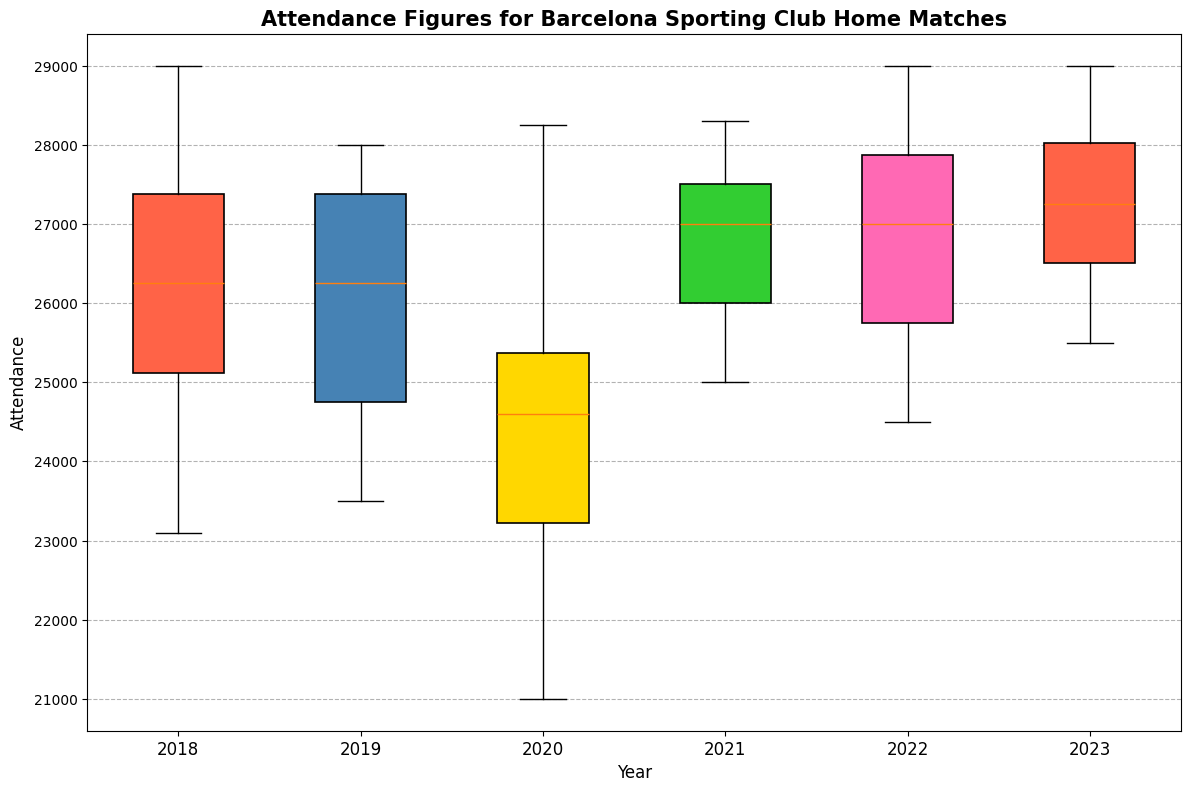Which year had the lowest median attendance? To find the year with the lowest median attendance, compare the median line within each box on the box plot for each year.
Answer: 2020 Which year had the highest median attendance? Check the median lines of each box plot and identify which one is at the highest position.
Answer: 2022 What is the interquartile range (IQR) for the year 2018? The IQR is the difference between the upper quartile (Q3) and the lower quartile (Q1). Locate these quartile boundaries on the box for 2018.
Answer: ~2750 In which year was the variability in attendance the highest? Identify the year with the largest range between the whiskers of the box plot, which represents the variability.
Answer: 2020 What is the range of attendance figures for 2021? The range is calculated by subtracting the minimum value (bottom whisker) from the maximum value (top whisker). Locate these two points on the 2021 box plot.
Answer: ~28500 - 25000 Did the attendance figures for the years 2022 and 2023 have any outliers? Examine the box plots for 2022 and 2023 to see if there are any markers that represent outliers outside the whiskers.
Answer: No Which year had the highest minimum attendance? The minimum attendance is indicated by the bottom whisker of each year’s box plot. The highest bottom whisker determines the year with the highest minimum attendance.
Answer: 2021 By how much did the median attendance change from 2020 to 2021? Determine the median for both years by locating the median line within each box and calculating the difference.
Answer: ~3500 Compare the average attendance for 2019 and 2020. Which one has a higher average and by how much? To compare averages, estimate the median for both years and account for the spread and symmetry of the data within the box. Then calculate the difference. The box plot shows higher spread and a higher median in 2019.
Answer: ~2500 higher in 2019 Was the attendance more consistent in 2023 compared to 2018? Consistency can be evaluated by comparing the lengths of the boxes (IQR) and the ranges (whiskers) for 2023 and 2018. Shorter boxes and whiskers indicate more consistency.
Answer: Yes 